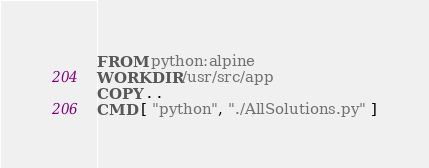<code> <loc_0><loc_0><loc_500><loc_500><_Dockerfile_>FROM python:alpine
WORKDIR /usr/src/app
COPY . .
CMD [ "python", "./AllSolutions.py" ]
</code> 